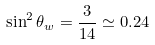Convert formula to latex. <formula><loc_0><loc_0><loc_500><loc_500>\sin ^ { 2 } \theta _ { w } = \frac { 3 } { 1 4 } \simeq 0 . 2 4</formula> 